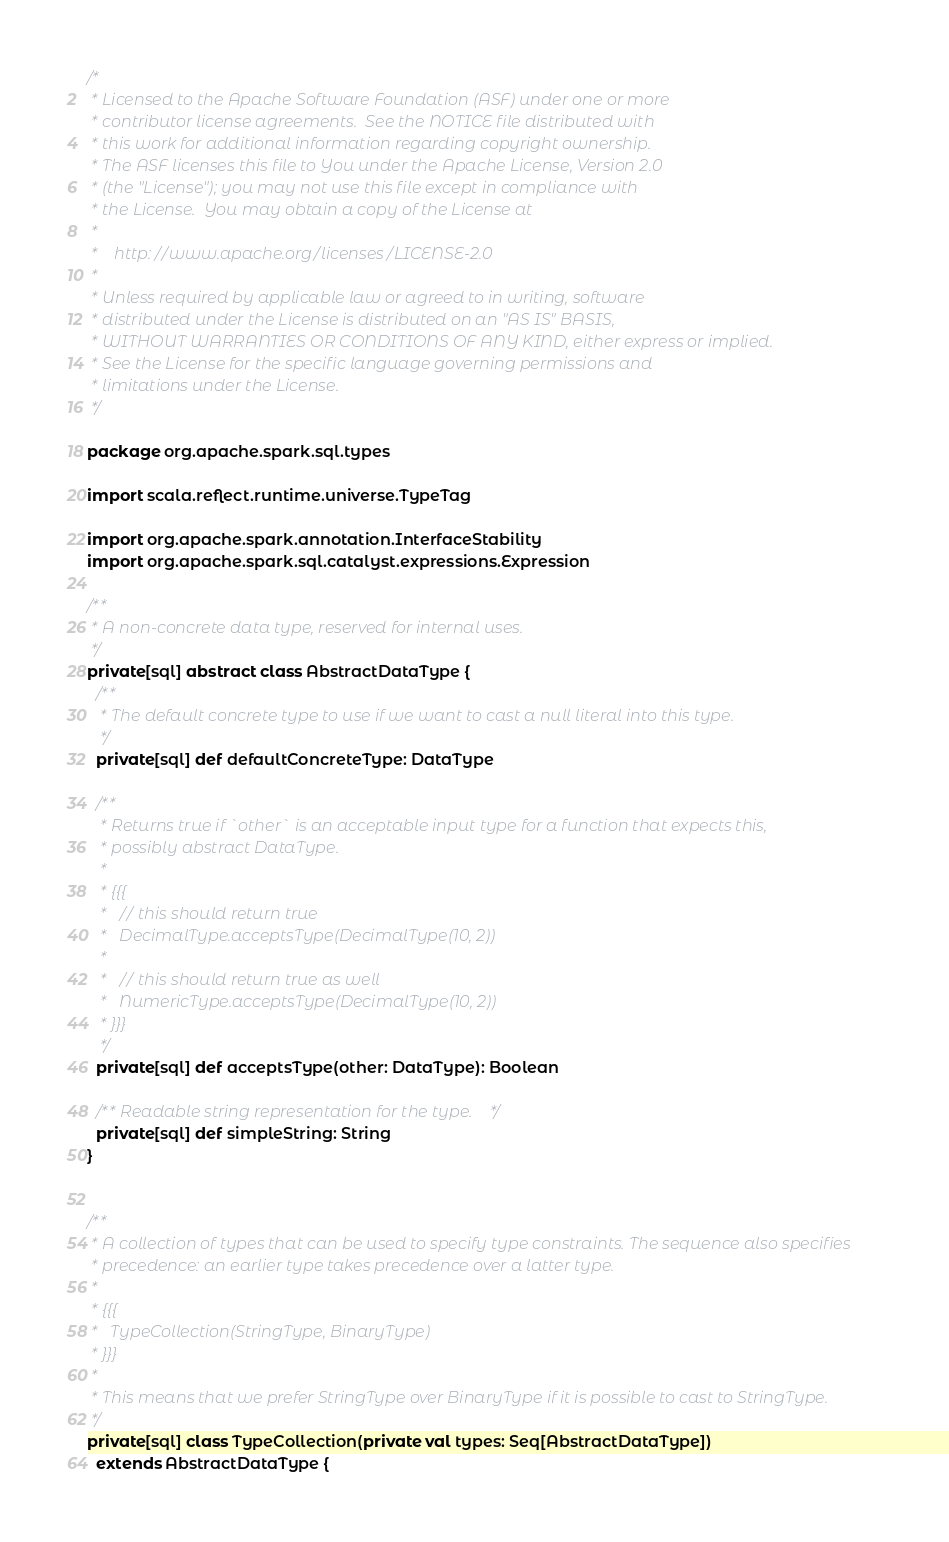Convert code to text. <code><loc_0><loc_0><loc_500><loc_500><_Scala_>/*
 * Licensed to the Apache Software Foundation (ASF) under one or more
 * contributor license agreements.  See the NOTICE file distributed with
 * this work for additional information regarding copyright ownership.
 * The ASF licenses this file to You under the Apache License, Version 2.0
 * (the "License"); you may not use this file except in compliance with
 * the License.  You may obtain a copy of the License at
 *
 *    http://www.apache.org/licenses/LICENSE-2.0
 *
 * Unless required by applicable law or agreed to in writing, software
 * distributed under the License is distributed on an "AS IS" BASIS,
 * WITHOUT WARRANTIES OR CONDITIONS OF ANY KIND, either express or implied.
 * See the License for the specific language governing permissions and
 * limitations under the License.
 */

package org.apache.spark.sql.types

import scala.reflect.runtime.universe.TypeTag

import org.apache.spark.annotation.InterfaceStability
import org.apache.spark.sql.catalyst.expressions.Expression

/**
 * A non-concrete data type, reserved for internal uses.
 */
private[sql] abstract class AbstractDataType {
  /**
   * The default concrete type to use if we want to cast a null literal into this type.
   */
  private[sql] def defaultConcreteType: DataType

  /**
   * Returns true if `other` is an acceptable input type for a function that expects this,
   * possibly abstract DataType.
   *
   * {{{
   *   // this should return true
   *   DecimalType.acceptsType(DecimalType(10, 2))
   *
   *   // this should return true as well
   *   NumericType.acceptsType(DecimalType(10, 2))
   * }}}
   */
  private[sql] def acceptsType(other: DataType): Boolean

  /** Readable string representation for the type. */
  private[sql] def simpleString: String
}


/**
 * A collection of types that can be used to specify type constraints. The sequence also specifies
 * precedence: an earlier type takes precedence over a latter type.
 *
 * {{{
 *   TypeCollection(StringType, BinaryType)
 * }}}
 *
 * This means that we prefer StringType over BinaryType if it is possible to cast to StringType.
 */
private[sql] class TypeCollection(private val types: Seq[AbstractDataType])
  extends AbstractDataType {
</code> 